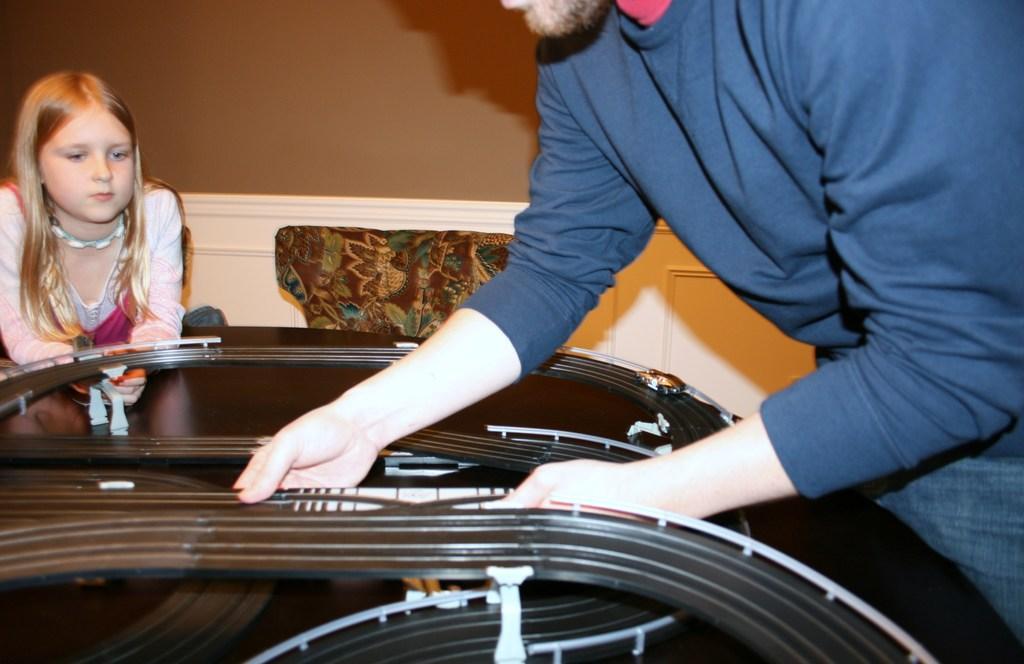How would you summarize this image in a sentence or two? In the image there is a man working with some equipment and behind the equipment there's a girl, in the background there is a wall. 